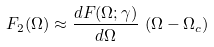<formula> <loc_0><loc_0><loc_500><loc_500>F _ { 2 } ( \Omega ) \approx \frac { d F ( \Omega ; \gamma ) } { d \Omega } \, \left ( \Omega - \Omega _ { c } \right )</formula> 